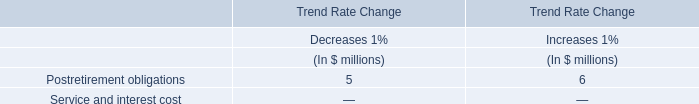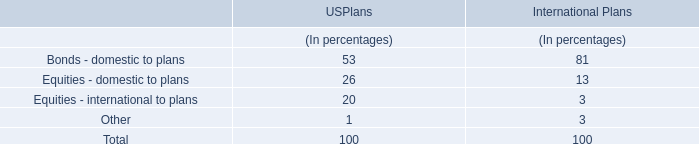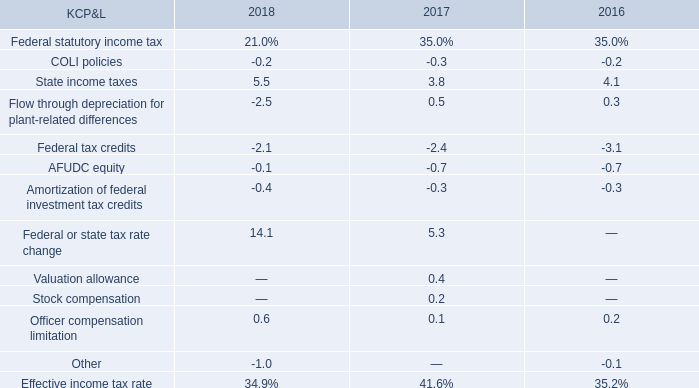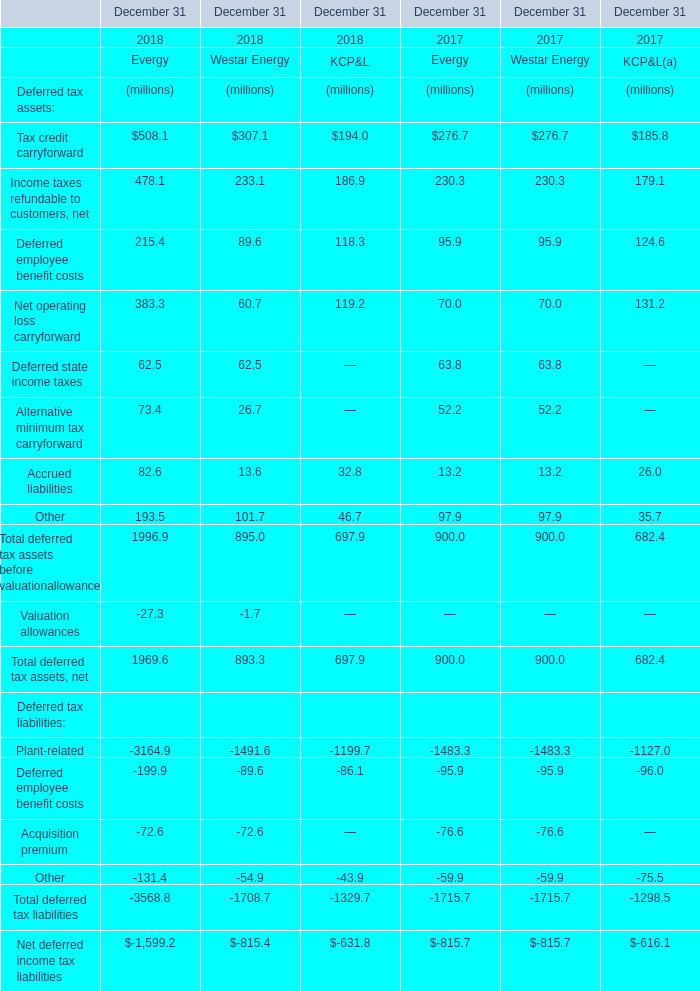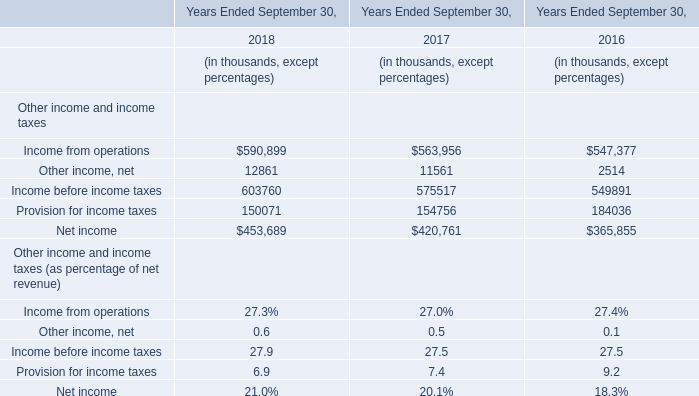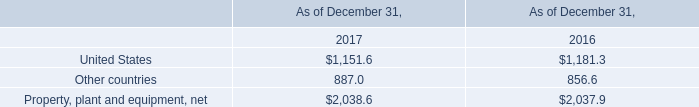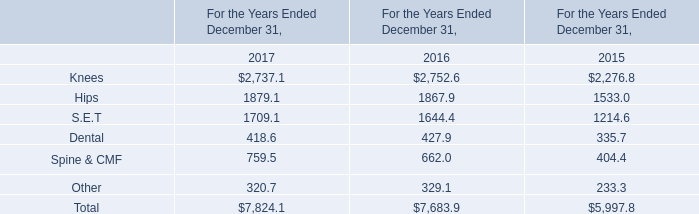What is the average value of Income taxes refundable to customers, net for Evergy , Westar Energy, and KCP&L ? (in million) 
Computations: (((478.1 + 233.1) + 186.9) / 3)
Answer: 299.36667. 